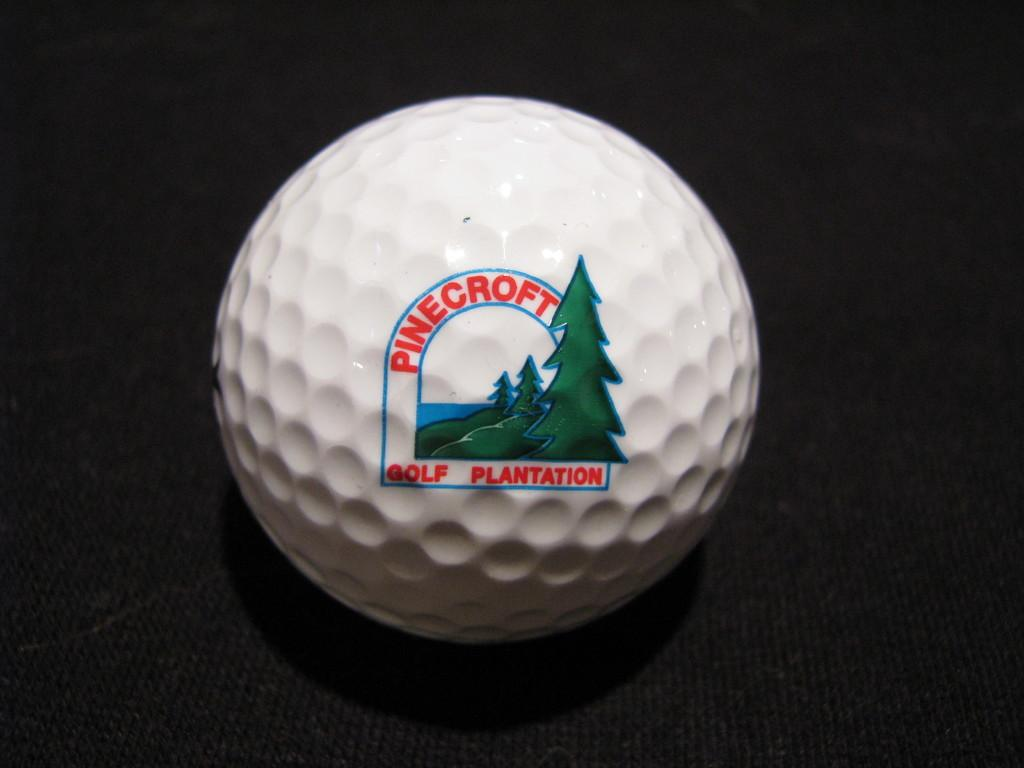<image>
Give a short and clear explanation of the subsequent image. A golf ball from Pinecroft Golf Plantation rests on a black surface. 